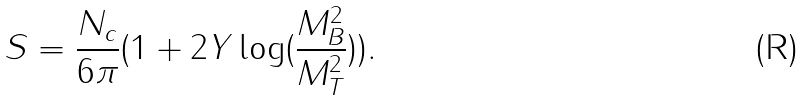Convert formula to latex. <formula><loc_0><loc_0><loc_500><loc_500>S = \frac { N _ { c } } { 6 \pi } ( 1 + 2 Y \log ( \frac { M _ { B } ^ { 2 } } { M _ { T } ^ { 2 } } ) ) .</formula> 